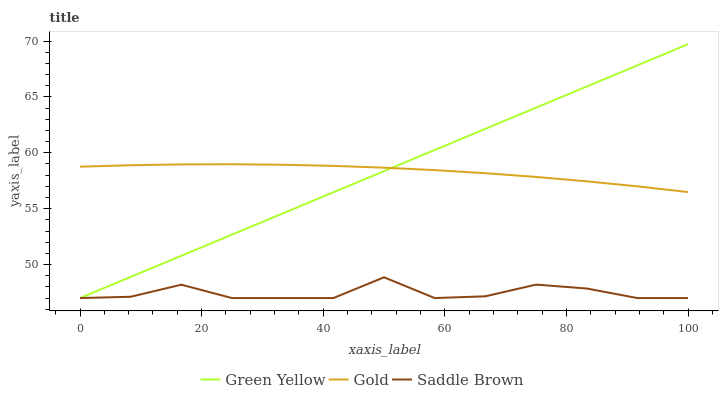Does Saddle Brown have the minimum area under the curve?
Answer yes or no. Yes. Does Green Yellow have the maximum area under the curve?
Answer yes or no. Yes. Does Gold have the minimum area under the curve?
Answer yes or no. No. Does Gold have the maximum area under the curve?
Answer yes or no. No. Is Green Yellow the smoothest?
Answer yes or no. Yes. Is Saddle Brown the roughest?
Answer yes or no. Yes. Is Gold the smoothest?
Answer yes or no. No. Is Gold the roughest?
Answer yes or no. No. Does Green Yellow have the lowest value?
Answer yes or no. Yes. Does Gold have the lowest value?
Answer yes or no. No. Does Green Yellow have the highest value?
Answer yes or no. Yes. Does Gold have the highest value?
Answer yes or no. No. Is Saddle Brown less than Gold?
Answer yes or no. Yes. Is Gold greater than Saddle Brown?
Answer yes or no. Yes. Does Gold intersect Green Yellow?
Answer yes or no. Yes. Is Gold less than Green Yellow?
Answer yes or no. No. Is Gold greater than Green Yellow?
Answer yes or no. No. Does Saddle Brown intersect Gold?
Answer yes or no. No. 